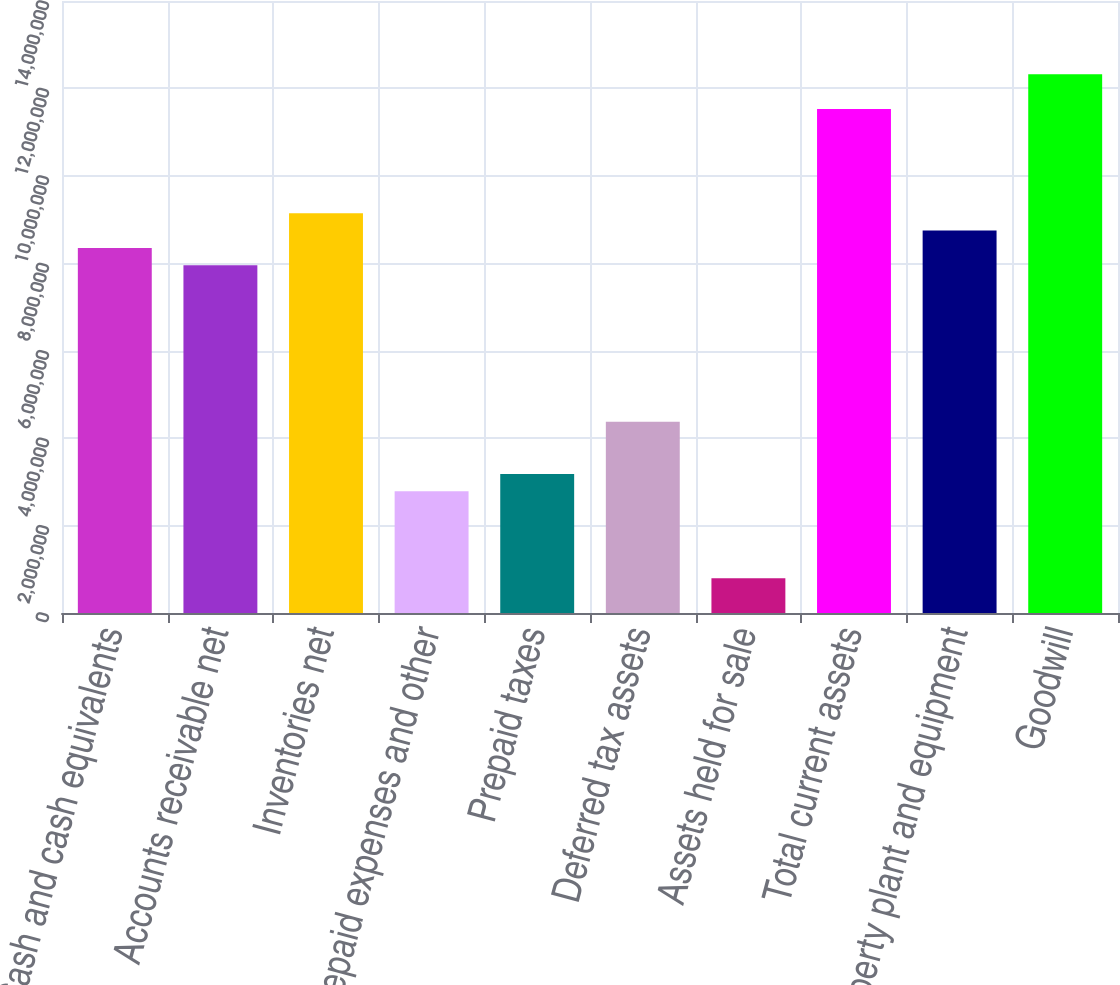<chart> <loc_0><loc_0><loc_500><loc_500><bar_chart><fcel>Cash and cash equivalents<fcel>Accounts receivable net<fcel>Inventories net<fcel>Prepaid expenses and other<fcel>Prepaid taxes<fcel>Deferred tax assets<fcel>Assets held for sale<fcel>Total current assets<fcel>Property plant and equipment<fcel>Goodwill<nl><fcel>8.35097e+06<fcel>7.95336e+06<fcel>9.14619e+06<fcel>2.78442e+06<fcel>3.18203e+06<fcel>4.37487e+06<fcel>796371<fcel>1.15319e+07<fcel>8.74858e+06<fcel>1.23271e+07<nl></chart> 